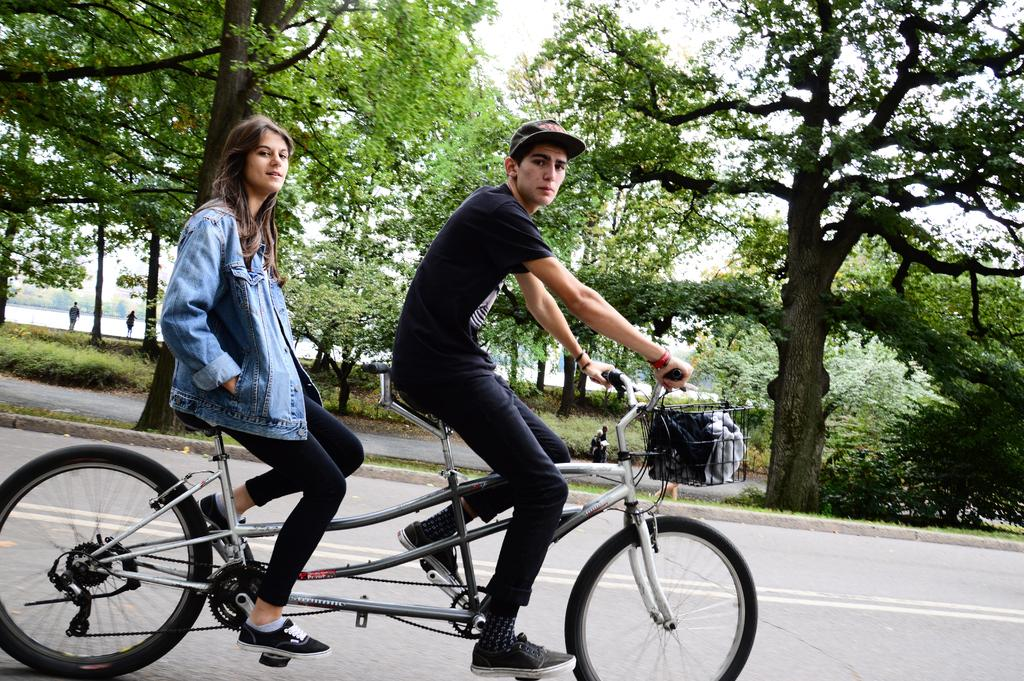How many people are in the image? There are 2 people in the image. What are the people doing in the image? The people are riding bicycles. Where are the people located in the image? They are on a road. What can be seen in the background of the image? There are trees and water visible in the background. What type of apple is being used as a prop in the image? There is no apple present in the image. What nation are the people in the image representing? The image does not provide information about the nationality of the people. 